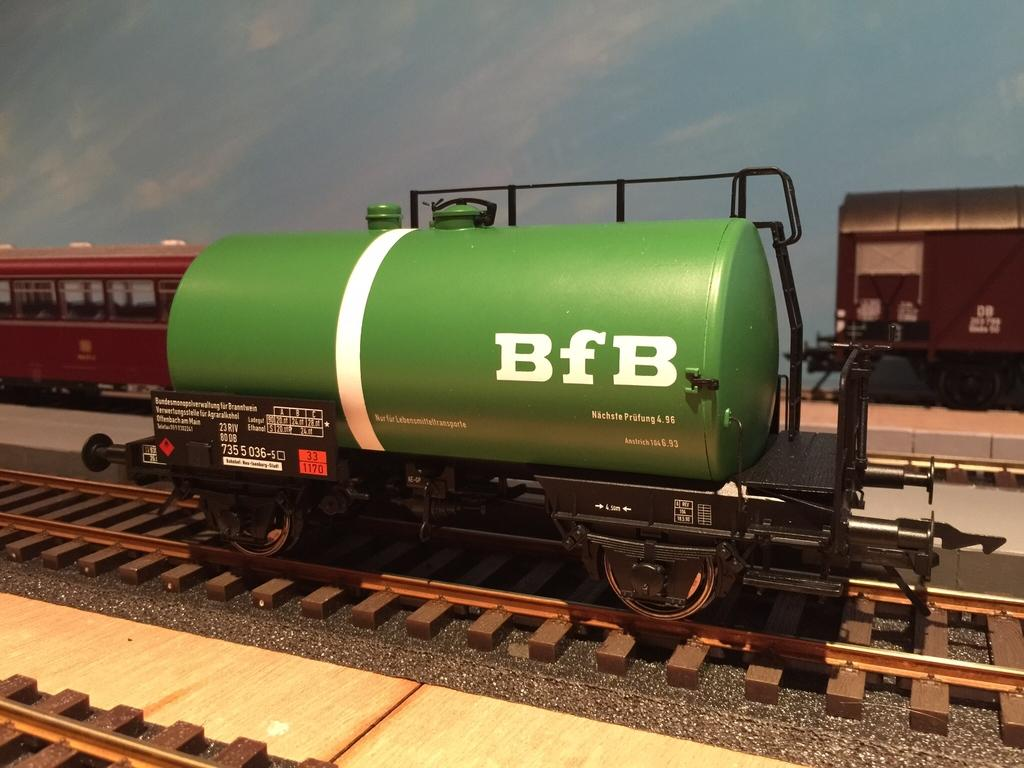What type of vehicles are in the image? There are scale model trains in the image. How are the trains positioned in the image? The trains are on tracks. What color is the background of the image? The background of the image is blue. What shape is the beast that is present in the image? There is no beast present in the image; it features scale model trains on tracks. What type of wire is used to connect the trains in the image? There is no visible wire connecting the trains in the image; the trains are on tracks. 